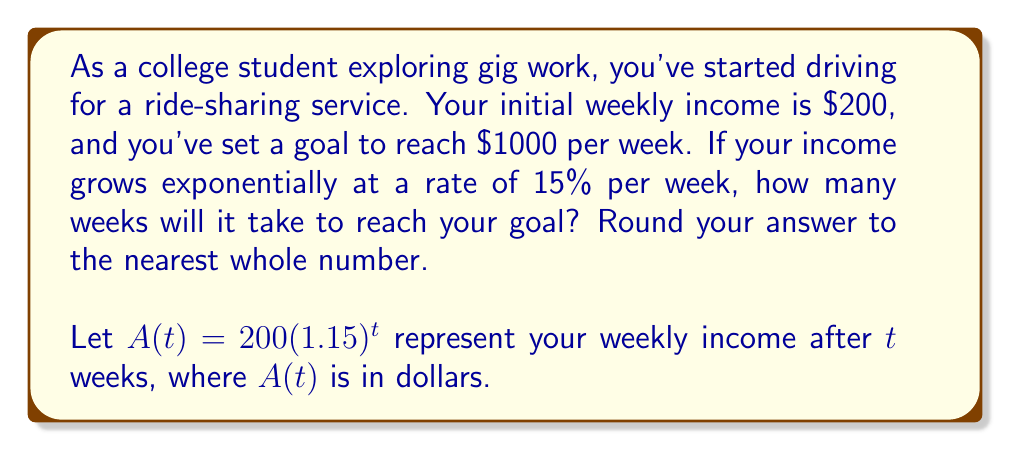Could you help me with this problem? To solve this problem, we'll use the exponential growth formula and solve for $t$:

1) The exponential growth formula is:
   $A(t) = A_0(1+r)^t$
   Where $A_0$ is the initial amount, $r$ is the growth rate, and $t$ is time.

2) In this case:
   $A_0 = 200$ (initial weekly income)
   $r = 0.15$ (15% growth rate)
   $A(t) = 1000$ (target income)

3) Plug these values into the formula:
   $1000 = 200(1.15)^t$

4) Divide both sides by 200:
   $5 = (1.15)^t$

5) Take the natural log of both sides:
   $\ln(5) = t \cdot \ln(1.15)$

6) Solve for $t$:
   $t = \frac{\ln(5)}{\ln(1.15)}$

7) Use a calculator to evaluate:
   $t \approx 11.619$

8) Round to the nearest whole number:
   $t \approx 12$
Answer: It will take approximately 12 weeks to reach the income goal of $1000 per week. 